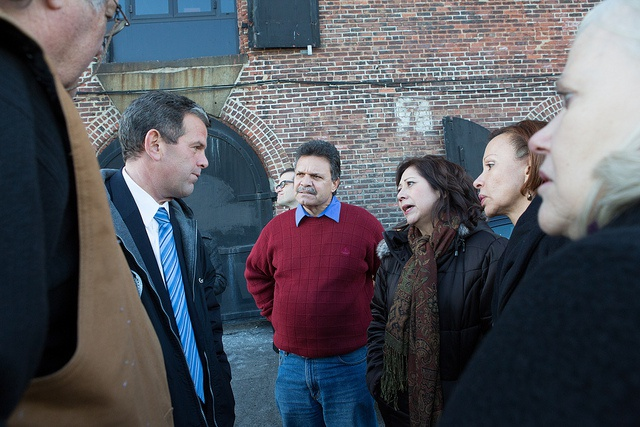Describe the objects in this image and their specific colors. I can see people in black, gray, and darkgray tones, people in black, lightgray, darkgray, and gray tones, people in black, maroon, navy, and brown tones, people in black and gray tones, and people in black, darkgray, gray, and navy tones in this image. 